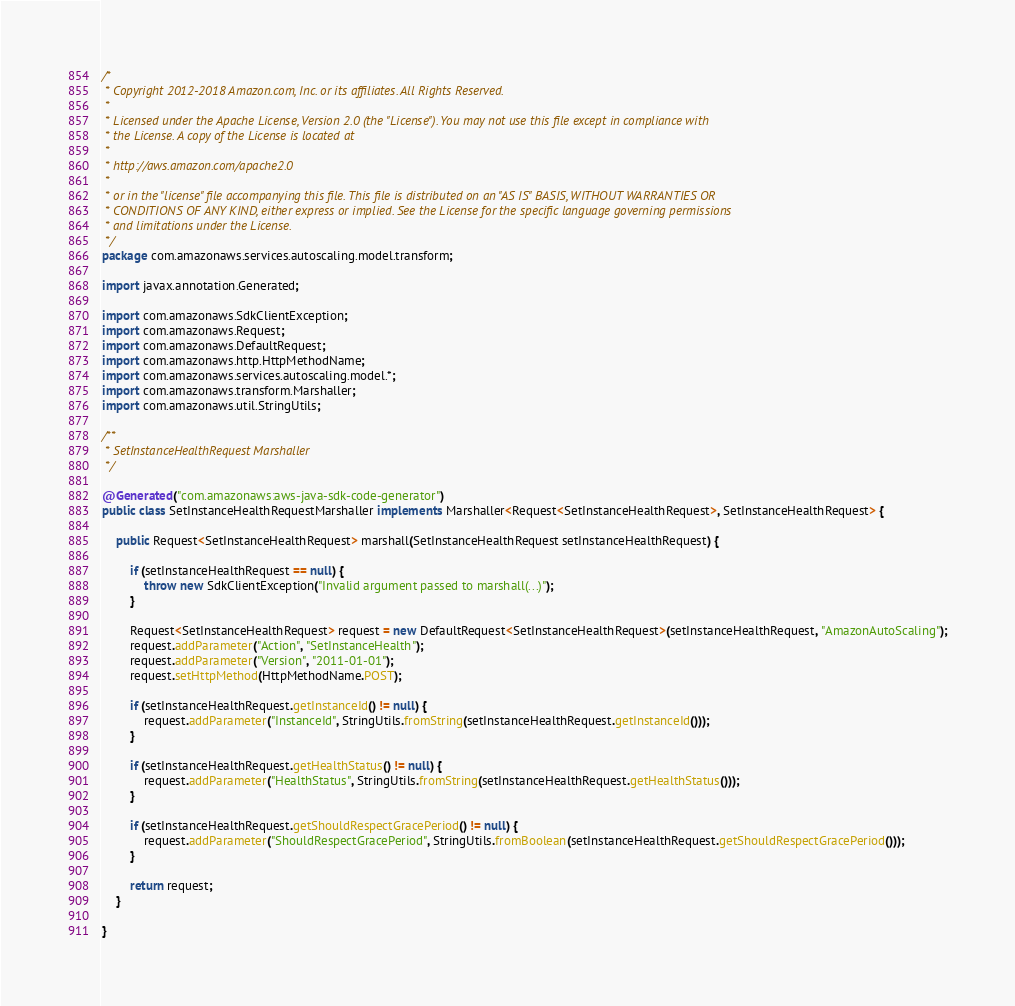Convert code to text. <code><loc_0><loc_0><loc_500><loc_500><_Java_>/*
 * Copyright 2012-2018 Amazon.com, Inc. or its affiliates. All Rights Reserved.
 * 
 * Licensed under the Apache License, Version 2.0 (the "License"). You may not use this file except in compliance with
 * the License. A copy of the License is located at
 * 
 * http://aws.amazon.com/apache2.0
 * 
 * or in the "license" file accompanying this file. This file is distributed on an "AS IS" BASIS, WITHOUT WARRANTIES OR
 * CONDITIONS OF ANY KIND, either express or implied. See the License for the specific language governing permissions
 * and limitations under the License.
 */
package com.amazonaws.services.autoscaling.model.transform;

import javax.annotation.Generated;

import com.amazonaws.SdkClientException;
import com.amazonaws.Request;
import com.amazonaws.DefaultRequest;
import com.amazonaws.http.HttpMethodName;
import com.amazonaws.services.autoscaling.model.*;
import com.amazonaws.transform.Marshaller;
import com.amazonaws.util.StringUtils;

/**
 * SetInstanceHealthRequest Marshaller
 */

@Generated("com.amazonaws:aws-java-sdk-code-generator")
public class SetInstanceHealthRequestMarshaller implements Marshaller<Request<SetInstanceHealthRequest>, SetInstanceHealthRequest> {

    public Request<SetInstanceHealthRequest> marshall(SetInstanceHealthRequest setInstanceHealthRequest) {

        if (setInstanceHealthRequest == null) {
            throw new SdkClientException("Invalid argument passed to marshall(...)");
        }

        Request<SetInstanceHealthRequest> request = new DefaultRequest<SetInstanceHealthRequest>(setInstanceHealthRequest, "AmazonAutoScaling");
        request.addParameter("Action", "SetInstanceHealth");
        request.addParameter("Version", "2011-01-01");
        request.setHttpMethod(HttpMethodName.POST);

        if (setInstanceHealthRequest.getInstanceId() != null) {
            request.addParameter("InstanceId", StringUtils.fromString(setInstanceHealthRequest.getInstanceId()));
        }

        if (setInstanceHealthRequest.getHealthStatus() != null) {
            request.addParameter("HealthStatus", StringUtils.fromString(setInstanceHealthRequest.getHealthStatus()));
        }

        if (setInstanceHealthRequest.getShouldRespectGracePeriod() != null) {
            request.addParameter("ShouldRespectGracePeriod", StringUtils.fromBoolean(setInstanceHealthRequest.getShouldRespectGracePeriod()));
        }

        return request;
    }

}
</code> 